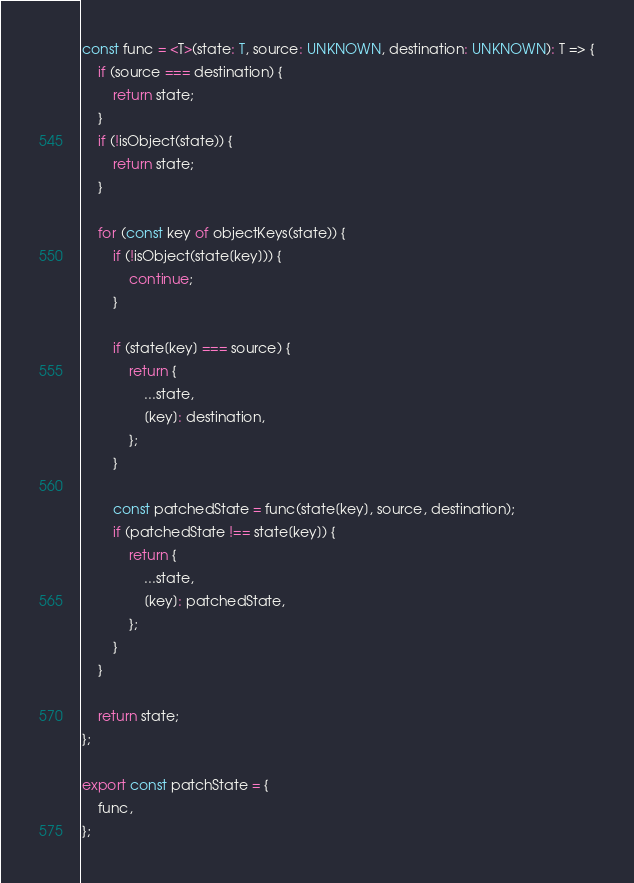<code> <loc_0><loc_0><loc_500><loc_500><_TypeScript_>
const func = <T>(state: T, source: UNKNOWN, destination: UNKNOWN): T => {
    if (source === destination) {
        return state;
    }
    if (!isObject(state)) {
        return state;
    }

    for (const key of objectKeys(state)) {
        if (!isObject(state[key])) {
            continue;
        }

        if (state[key] === source) {
            return {
                ...state,
                [key]: destination,
            };
        }

        const patchedState = func(state[key], source, destination);
        if (patchedState !== state[key]) {
            return {
                ...state,
                [key]: patchedState,
            };
        }
    }

    return state;
};

export const patchState = {
    func,
};
</code> 